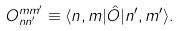<formula> <loc_0><loc_0><loc_500><loc_500>O _ { n n ^ { \prime } } ^ { m m ^ { \prime } } \equiv \langle n , m | \hat { O } | n ^ { \prime } , m ^ { \prime } \rangle .</formula> 